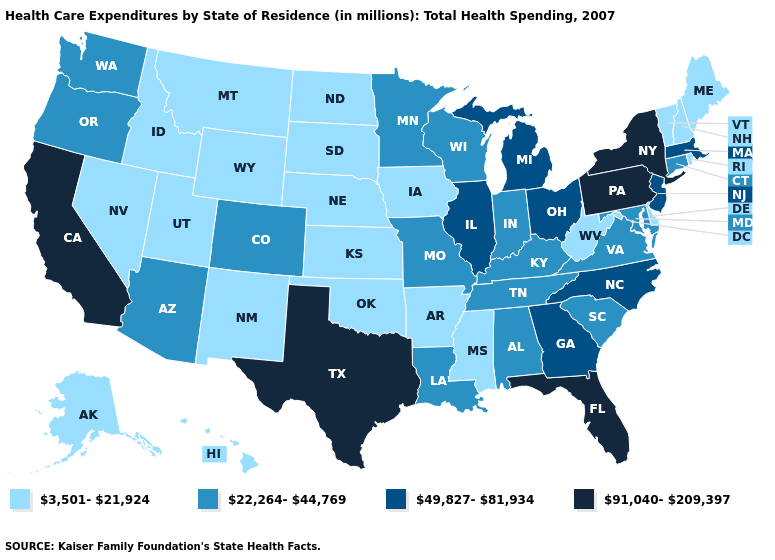Among the states that border Delaware , which have the highest value?
Concise answer only. Pennsylvania. What is the value of Nebraska?
Give a very brief answer. 3,501-21,924. Which states hav the highest value in the Northeast?
Quick response, please. New York, Pennsylvania. What is the lowest value in the MidWest?
Keep it brief. 3,501-21,924. What is the lowest value in the USA?
Concise answer only. 3,501-21,924. Is the legend a continuous bar?
Answer briefly. No. Name the states that have a value in the range 22,264-44,769?
Give a very brief answer. Alabama, Arizona, Colorado, Connecticut, Indiana, Kentucky, Louisiana, Maryland, Minnesota, Missouri, Oregon, South Carolina, Tennessee, Virginia, Washington, Wisconsin. Among the states that border Oklahoma , which have the highest value?
Write a very short answer. Texas. Is the legend a continuous bar?
Write a very short answer. No. Among the states that border Nebraska , which have the highest value?
Answer briefly. Colorado, Missouri. Among the states that border Kansas , which have the lowest value?
Write a very short answer. Nebraska, Oklahoma. Name the states that have a value in the range 3,501-21,924?
Concise answer only. Alaska, Arkansas, Delaware, Hawaii, Idaho, Iowa, Kansas, Maine, Mississippi, Montana, Nebraska, Nevada, New Hampshire, New Mexico, North Dakota, Oklahoma, Rhode Island, South Dakota, Utah, Vermont, West Virginia, Wyoming. What is the value of Utah?
Quick response, please. 3,501-21,924. Is the legend a continuous bar?
Quick response, please. No. What is the value of California?
Write a very short answer. 91,040-209,397. 